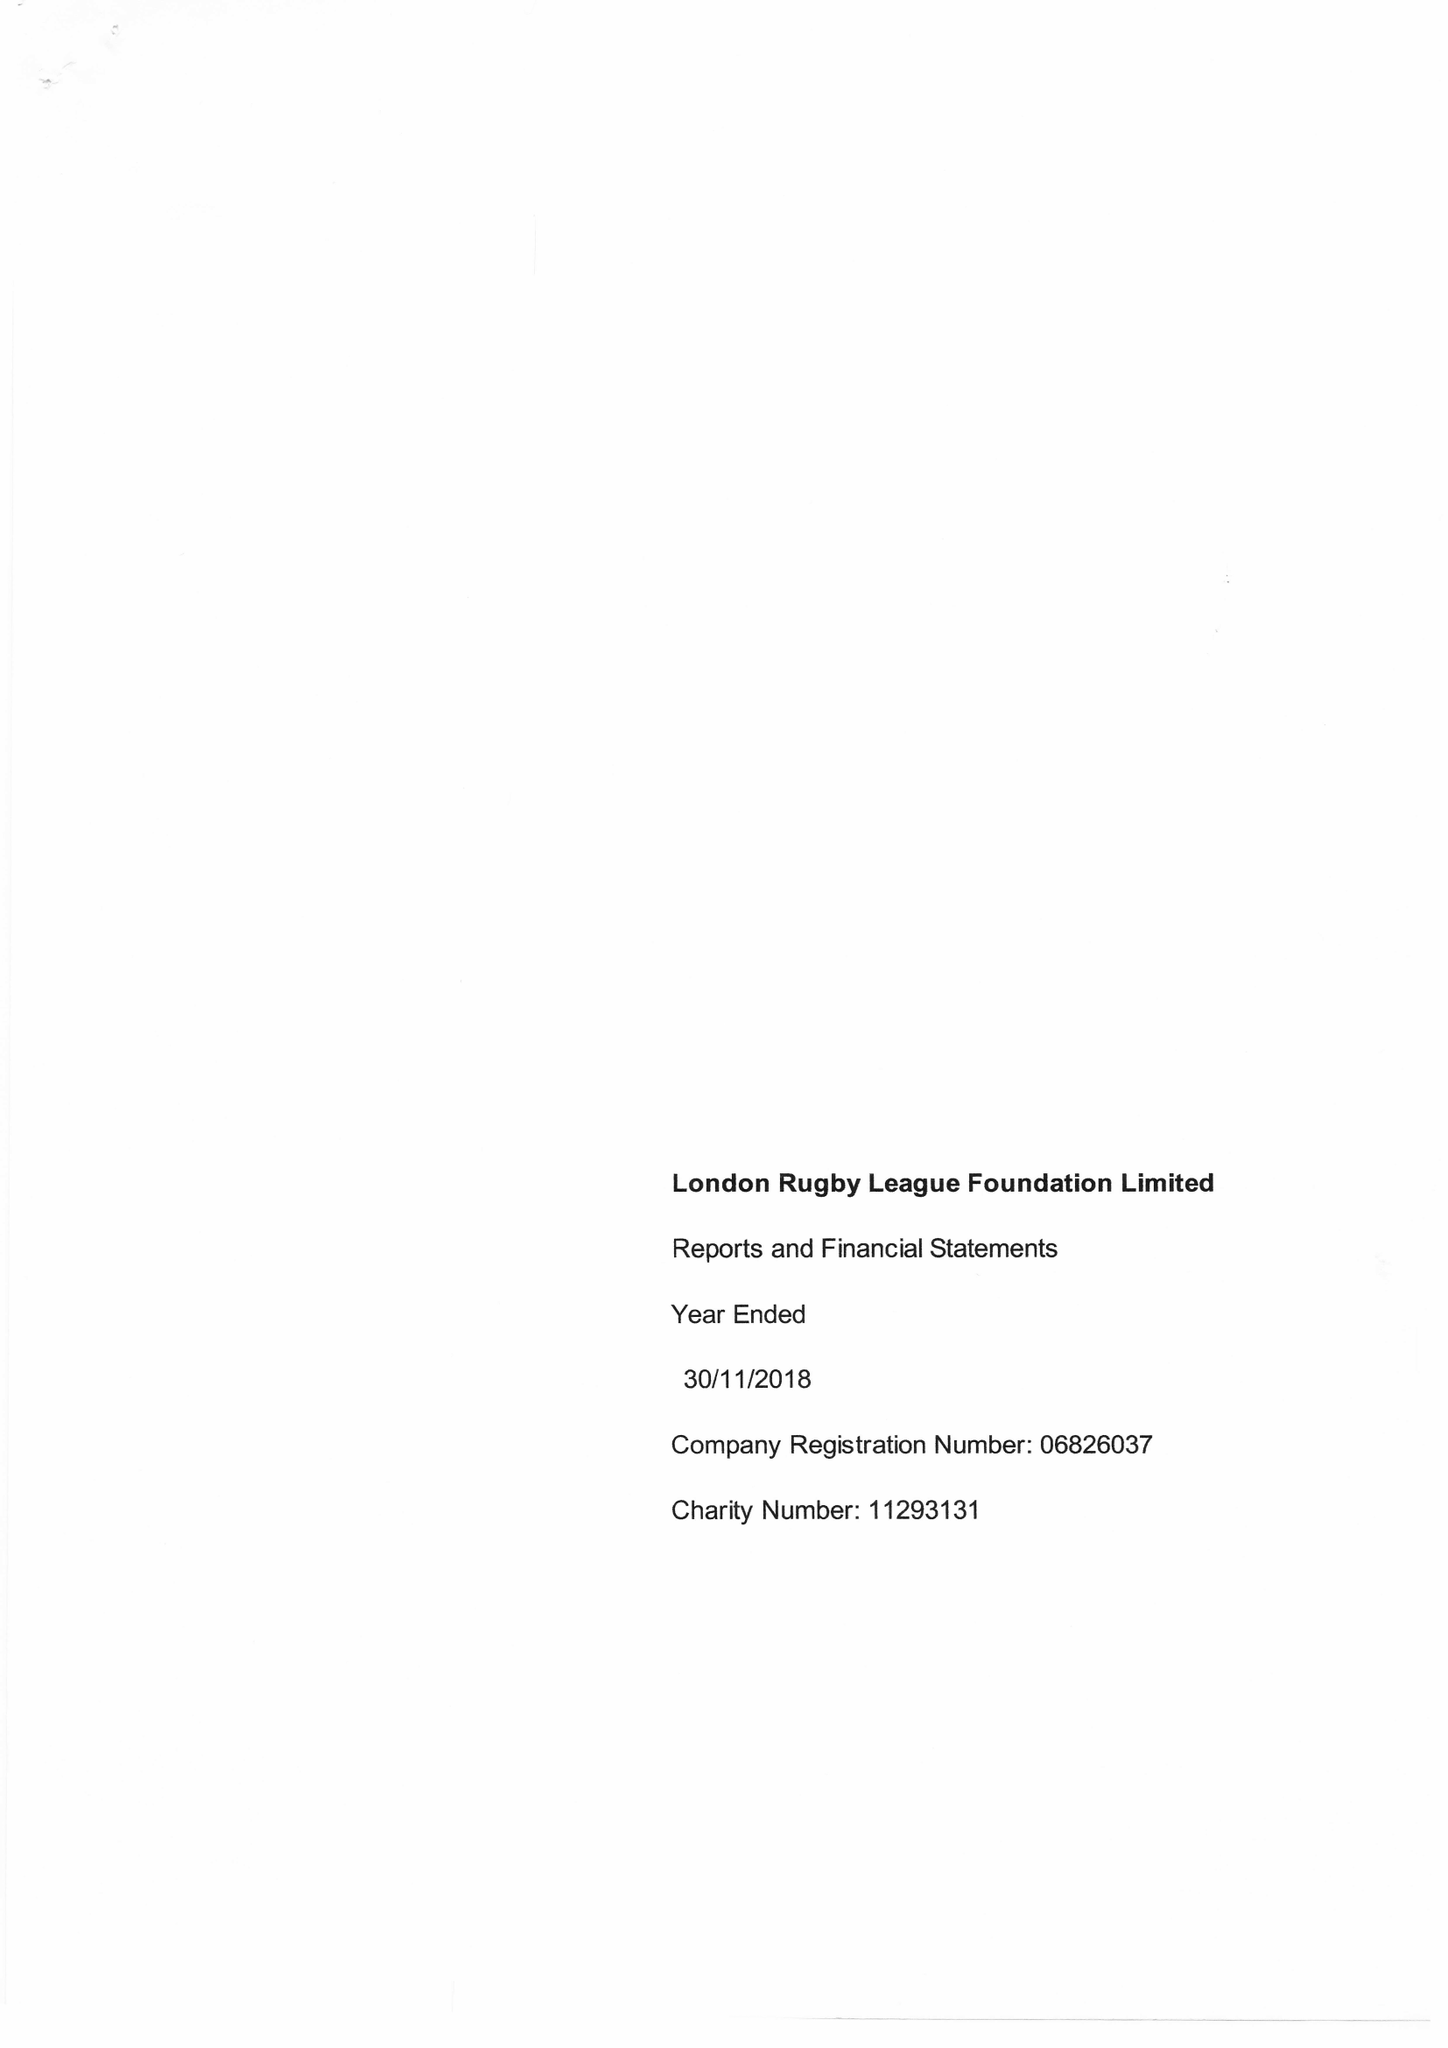What is the value for the charity_number?
Answer the question using a single word or phrase. 1129131 